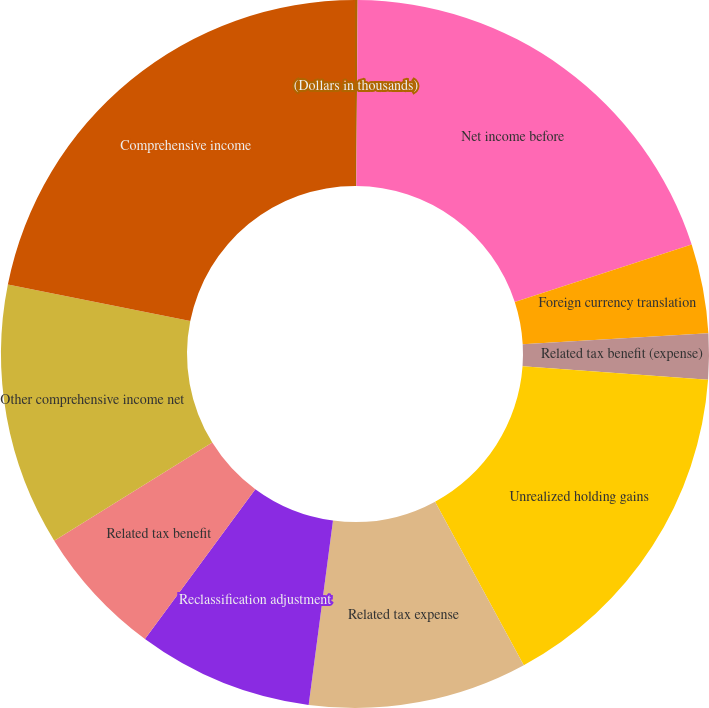<chart> <loc_0><loc_0><loc_500><loc_500><pie_chart><fcel>(Dollars in thousands)<fcel>Net income before<fcel>Foreign currency translation<fcel>Related tax benefit (expense)<fcel>Unrealized holding gains<fcel>Related tax expense<fcel>Reclassification adjustment<fcel>Related tax benefit<fcel>Other comprehensive income net<fcel>Comprehensive income<nl><fcel>0.12%<fcel>19.88%<fcel>4.07%<fcel>2.09%<fcel>15.93%<fcel>10.0%<fcel>8.02%<fcel>6.05%<fcel>11.98%<fcel>21.86%<nl></chart> 